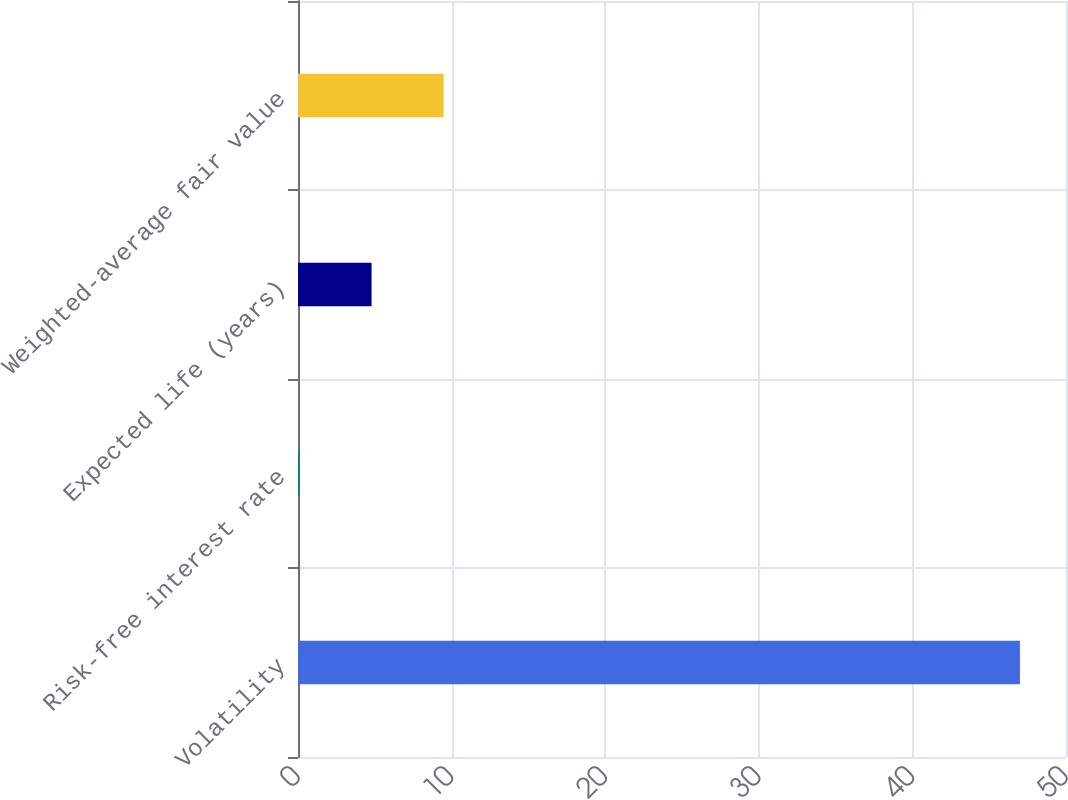Convert chart to OTSL. <chart><loc_0><loc_0><loc_500><loc_500><bar_chart><fcel>Volatility<fcel>Risk-free interest rate<fcel>Expected life (years)<fcel>Weighted-average fair value<nl><fcel>47<fcel>0.1<fcel>4.79<fcel>9.48<nl></chart> 